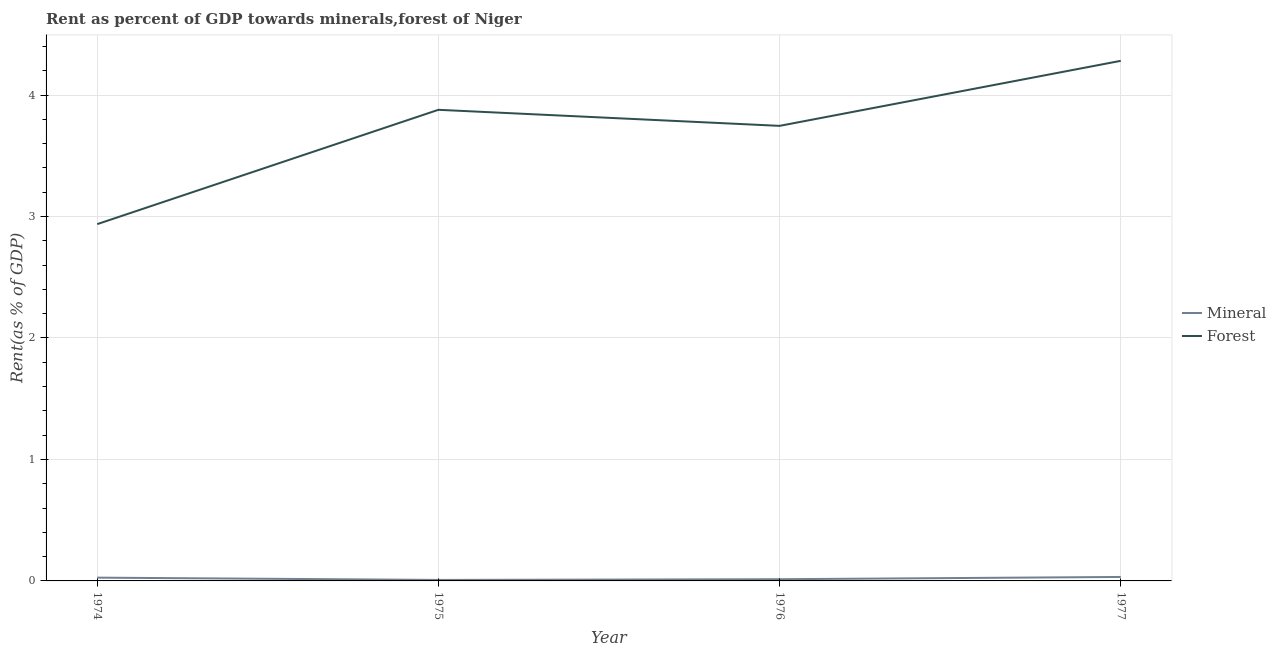What is the mineral rent in 1976?
Offer a terse response. 0.01. Across all years, what is the maximum mineral rent?
Give a very brief answer. 0.03. Across all years, what is the minimum forest rent?
Ensure brevity in your answer.  2.94. In which year was the forest rent minimum?
Your response must be concise. 1974. What is the total forest rent in the graph?
Offer a terse response. 14.84. What is the difference between the forest rent in 1976 and that in 1977?
Offer a terse response. -0.54. What is the difference between the mineral rent in 1974 and the forest rent in 1975?
Your answer should be compact. -3.85. What is the average mineral rent per year?
Provide a short and direct response. 0.02. In the year 1976, what is the difference between the forest rent and mineral rent?
Provide a short and direct response. 3.73. What is the ratio of the forest rent in 1974 to that in 1975?
Provide a short and direct response. 0.76. Is the difference between the forest rent in 1974 and 1977 greater than the difference between the mineral rent in 1974 and 1977?
Offer a terse response. No. What is the difference between the highest and the second highest forest rent?
Provide a short and direct response. 0.4. What is the difference between the highest and the lowest forest rent?
Offer a terse response. 1.34. Is the forest rent strictly greater than the mineral rent over the years?
Give a very brief answer. Yes. How many lines are there?
Your answer should be very brief. 2. Where does the legend appear in the graph?
Your answer should be compact. Center right. How are the legend labels stacked?
Ensure brevity in your answer.  Vertical. What is the title of the graph?
Make the answer very short. Rent as percent of GDP towards minerals,forest of Niger. What is the label or title of the X-axis?
Your answer should be compact. Year. What is the label or title of the Y-axis?
Provide a short and direct response. Rent(as % of GDP). What is the Rent(as % of GDP) in Mineral in 1974?
Make the answer very short. 0.03. What is the Rent(as % of GDP) of Forest in 1974?
Provide a succinct answer. 2.94. What is the Rent(as % of GDP) of Mineral in 1975?
Your response must be concise. 0.01. What is the Rent(as % of GDP) of Forest in 1975?
Ensure brevity in your answer.  3.88. What is the Rent(as % of GDP) of Mineral in 1976?
Ensure brevity in your answer.  0.01. What is the Rent(as % of GDP) of Forest in 1976?
Your answer should be compact. 3.75. What is the Rent(as % of GDP) of Mineral in 1977?
Ensure brevity in your answer.  0.03. What is the Rent(as % of GDP) of Forest in 1977?
Provide a succinct answer. 4.28. Across all years, what is the maximum Rent(as % of GDP) of Mineral?
Your answer should be compact. 0.03. Across all years, what is the maximum Rent(as % of GDP) of Forest?
Your answer should be very brief. 4.28. Across all years, what is the minimum Rent(as % of GDP) in Mineral?
Ensure brevity in your answer.  0.01. Across all years, what is the minimum Rent(as % of GDP) in Forest?
Ensure brevity in your answer.  2.94. What is the total Rent(as % of GDP) in Mineral in the graph?
Your answer should be compact. 0.08. What is the total Rent(as % of GDP) of Forest in the graph?
Offer a very short reply. 14.84. What is the difference between the Rent(as % of GDP) in Mineral in 1974 and that in 1975?
Offer a very short reply. 0.02. What is the difference between the Rent(as % of GDP) of Forest in 1974 and that in 1975?
Ensure brevity in your answer.  -0.94. What is the difference between the Rent(as % of GDP) of Mineral in 1974 and that in 1976?
Make the answer very short. 0.01. What is the difference between the Rent(as % of GDP) in Forest in 1974 and that in 1976?
Provide a short and direct response. -0.81. What is the difference between the Rent(as % of GDP) in Mineral in 1974 and that in 1977?
Your answer should be compact. -0.01. What is the difference between the Rent(as % of GDP) in Forest in 1974 and that in 1977?
Make the answer very short. -1.34. What is the difference between the Rent(as % of GDP) in Mineral in 1975 and that in 1976?
Offer a very short reply. -0.01. What is the difference between the Rent(as % of GDP) in Forest in 1975 and that in 1976?
Keep it short and to the point. 0.13. What is the difference between the Rent(as % of GDP) in Mineral in 1975 and that in 1977?
Provide a succinct answer. -0.02. What is the difference between the Rent(as % of GDP) in Forest in 1975 and that in 1977?
Your answer should be very brief. -0.4. What is the difference between the Rent(as % of GDP) of Mineral in 1976 and that in 1977?
Give a very brief answer. -0.02. What is the difference between the Rent(as % of GDP) of Forest in 1976 and that in 1977?
Provide a short and direct response. -0.54. What is the difference between the Rent(as % of GDP) in Mineral in 1974 and the Rent(as % of GDP) in Forest in 1975?
Ensure brevity in your answer.  -3.85. What is the difference between the Rent(as % of GDP) in Mineral in 1974 and the Rent(as % of GDP) in Forest in 1976?
Keep it short and to the point. -3.72. What is the difference between the Rent(as % of GDP) of Mineral in 1974 and the Rent(as % of GDP) of Forest in 1977?
Offer a terse response. -4.25. What is the difference between the Rent(as % of GDP) of Mineral in 1975 and the Rent(as % of GDP) of Forest in 1976?
Your answer should be very brief. -3.74. What is the difference between the Rent(as % of GDP) in Mineral in 1975 and the Rent(as % of GDP) in Forest in 1977?
Give a very brief answer. -4.27. What is the difference between the Rent(as % of GDP) of Mineral in 1976 and the Rent(as % of GDP) of Forest in 1977?
Provide a short and direct response. -4.27. What is the average Rent(as % of GDP) of Mineral per year?
Your response must be concise. 0.02. What is the average Rent(as % of GDP) in Forest per year?
Your answer should be compact. 3.71. In the year 1974, what is the difference between the Rent(as % of GDP) in Mineral and Rent(as % of GDP) in Forest?
Keep it short and to the point. -2.91. In the year 1975, what is the difference between the Rent(as % of GDP) of Mineral and Rent(as % of GDP) of Forest?
Provide a short and direct response. -3.87. In the year 1976, what is the difference between the Rent(as % of GDP) of Mineral and Rent(as % of GDP) of Forest?
Provide a succinct answer. -3.73. In the year 1977, what is the difference between the Rent(as % of GDP) in Mineral and Rent(as % of GDP) in Forest?
Provide a succinct answer. -4.25. What is the ratio of the Rent(as % of GDP) in Mineral in 1974 to that in 1975?
Offer a terse response. 3.29. What is the ratio of the Rent(as % of GDP) of Forest in 1974 to that in 1975?
Ensure brevity in your answer.  0.76. What is the ratio of the Rent(as % of GDP) of Mineral in 1974 to that in 1976?
Give a very brief answer. 1.92. What is the ratio of the Rent(as % of GDP) in Forest in 1974 to that in 1976?
Provide a short and direct response. 0.78. What is the ratio of the Rent(as % of GDP) of Mineral in 1974 to that in 1977?
Provide a short and direct response. 0.82. What is the ratio of the Rent(as % of GDP) in Forest in 1974 to that in 1977?
Offer a terse response. 0.69. What is the ratio of the Rent(as % of GDP) of Mineral in 1975 to that in 1976?
Your response must be concise. 0.58. What is the ratio of the Rent(as % of GDP) of Forest in 1975 to that in 1976?
Your answer should be very brief. 1.04. What is the ratio of the Rent(as % of GDP) of Mineral in 1975 to that in 1977?
Offer a very short reply. 0.25. What is the ratio of the Rent(as % of GDP) of Forest in 1975 to that in 1977?
Your response must be concise. 0.91. What is the ratio of the Rent(as % of GDP) of Mineral in 1976 to that in 1977?
Your answer should be compact. 0.43. What is the ratio of the Rent(as % of GDP) of Forest in 1976 to that in 1977?
Give a very brief answer. 0.88. What is the difference between the highest and the second highest Rent(as % of GDP) of Mineral?
Your answer should be very brief. 0.01. What is the difference between the highest and the second highest Rent(as % of GDP) in Forest?
Provide a succinct answer. 0.4. What is the difference between the highest and the lowest Rent(as % of GDP) of Mineral?
Provide a short and direct response. 0.02. What is the difference between the highest and the lowest Rent(as % of GDP) in Forest?
Ensure brevity in your answer.  1.34. 